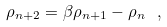Convert formula to latex. <formula><loc_0><loc_0><loc_500><loc_500>\rho _ { n + 2 } = \beta \rho _ { n + 1 } - \rho _ { n } \ ,</formula> 